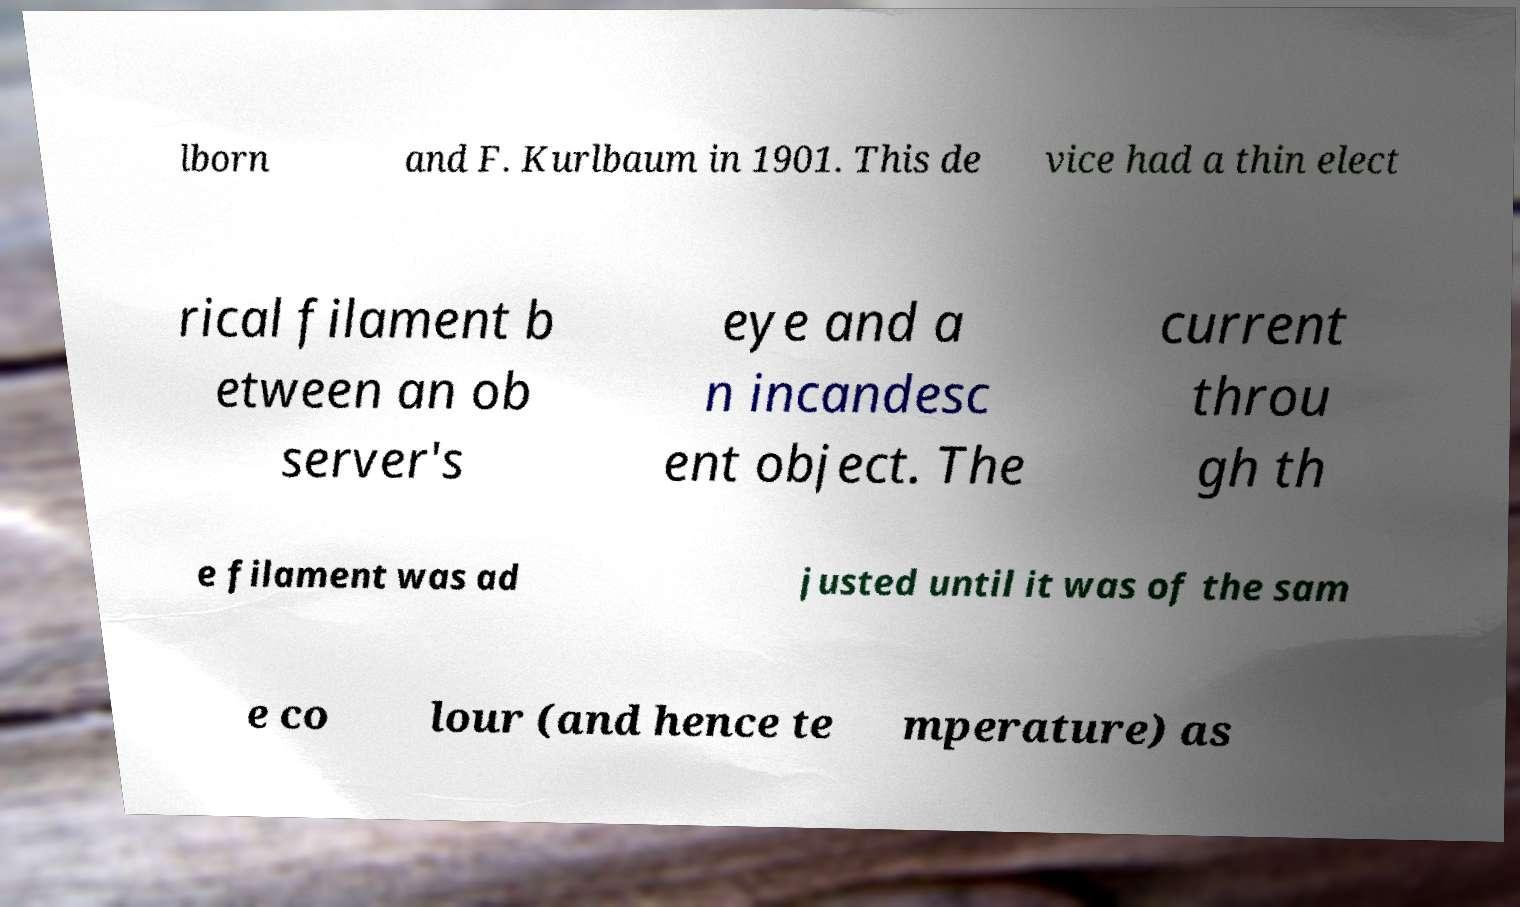Could you assist in decoding the text presented in this image and type it out clearly? lborn and F. Kurlbaum in 1901. This de vice had a thin elect rical filament b etween an ob server's eye and a n incandesc ent object. The current throu gh th e filament was ad justed until it was of the sam e co lour (and hence te mperature) as 